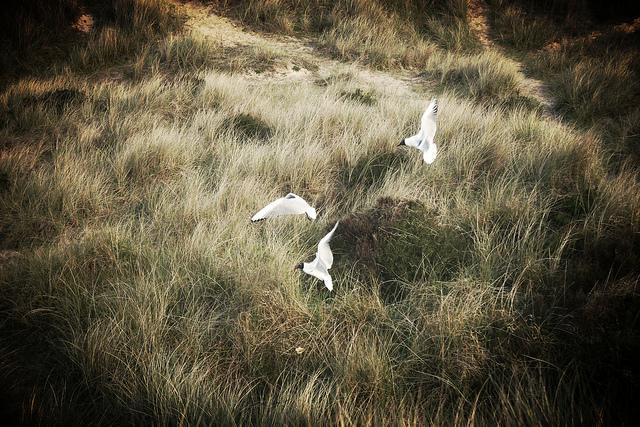What color are the beaks of these birds?
Choose the correct response, then elucidate: 'Answer: answer
Rationale: rationale.'
Options: Green, yellow, orange, black. Answer: black.
Rationale: The birds' beaks are black. 